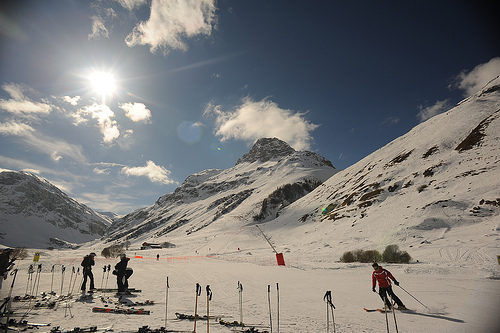Are there either orange fences or bowls? Yes, there is an orange fence visible, typically used in ski areas for marking boundaries or creating lanes. 